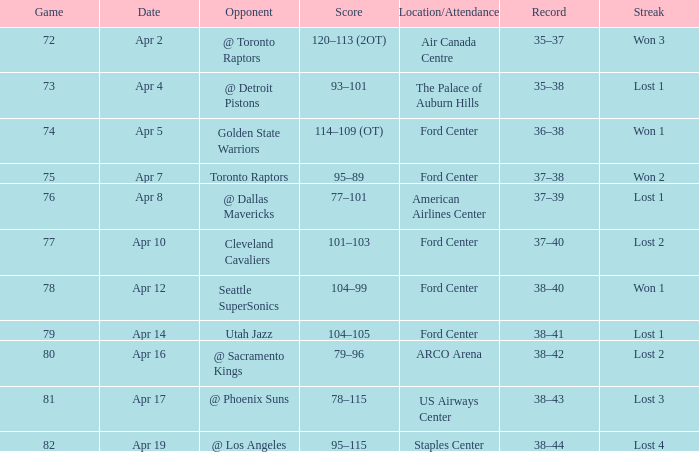Write the full table. {'header': ['Game', 'Date', 'Opponent', 'Score', 'Location/Attendance', 'Record', 'Streak'], 'rows': [['72', 'Apr 2', '@ Toronto Raptors', '120–113 (2OT)', 'Air Canada Centre', '35–37', 'Won 3'], ['73', 'Apr 4', '@ Detroit Pistons', '93–101', 'The Palace of Auburn Hills', '35–38', 'Lost 1'], ['74', 'Apr 5', 'Golden State Warriors', '114–109 (OT)', 'Ford Center', '36–38', 'Won 1'], ['75', 'Apr 7', 'Toronto Raptors', '95–89', 'Ford Center', '37–38', 'Won 2'], ['76', 'Apr 8', '@ Dallas Mavericks', '77–101', 'American Airlines Center', '37–39', 'Lost 1'], ['77', 'Apr 10', 'Cleveland Cavaliers', '101–103', 'Ford Center', '37–40', 'Lost 2'], ['78', 'Apr 12', 'Seattle SuperSonics', '104–99', 'Ford Center', '38–40', 'Won 1'], ['79', 'Apr 14', 'Utah Jazz', '104–105', 'Ford Center', '38–41', 'Lost 1'], ['80', 'Apr 16', '@ Sacramento Kings', '79–96', 'ARCO Arena', '38–42', 'Lost 2'], ['81', 'Apr 17', '@ Phoenix Suns', '78–115', 'US Airways Center', '38–43', 'Lost 3'], ['82', 'Apr 19', '@ Los Angeles', '95–115', 'Staples Center', '38–44', 'Lost 4']]} For a score of 114-109 (ot) and less than 78 games, what was the record? 36–38. 